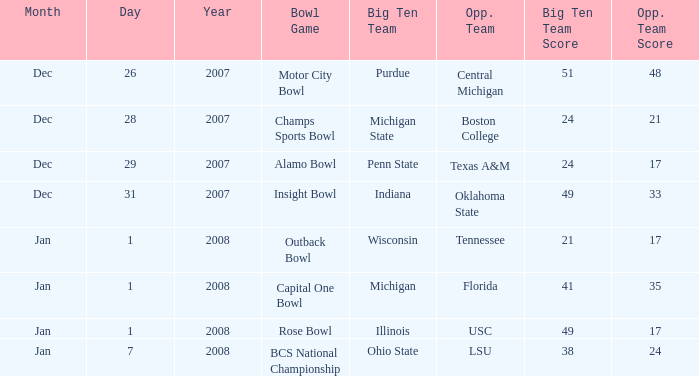What was the score of the BCS National Championship game? 38-24. 